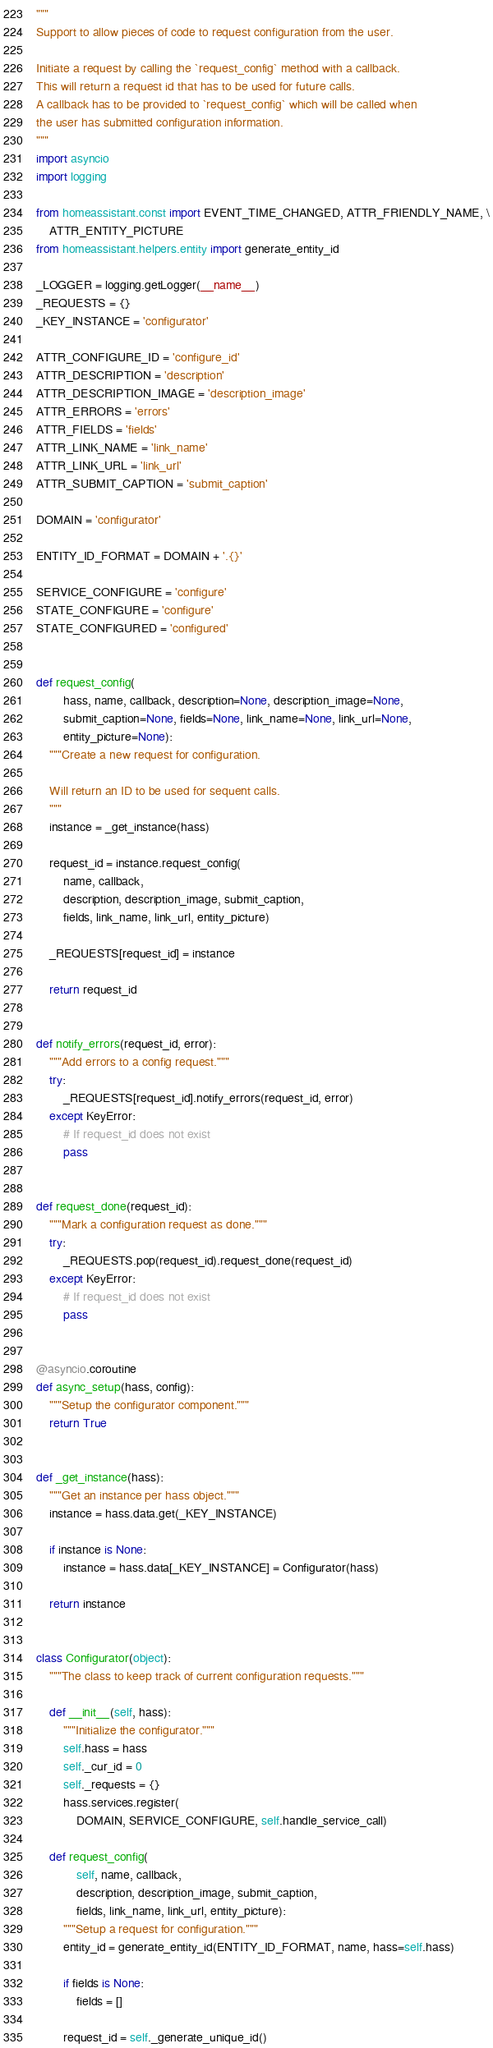Convert code to text. <code><loc_0><loc_0><loc_500><loc_500><_Python_>"""
Support to allow pieces of code to request configuration from the user.

Initiate a request by calling the `request_config` method with a callback.
This will return a request id that has to be used for future calls.
A callback has to be provided to `request_config` which will be called when
the user has submitted configuration information.
"""
import asyncio
import logging

from homeassistant.const import EVENT_TIME_CHANGED, ATTR_FRIENDLY_NAME, \
    ATTR_ENTITY_PICTURE
from homeassistant.helpers.entity import generate_entity_id

_LOGGER = logging.getLogger(__name__)
_REQUESTS = {}
_KEY_INSTANCE = 'configurator'

ATTR_CONFIGURE_ID = 'configure_id'
ATTR_DESCRIPTION = 'description'
ATTR_DESCRIPTION_IMAGE = 'description_image'
ATTR_ERRORS = 'errors'
ATTR_FIELDS = 'fields'
ATTR_LINK_NAME = 'link_name'
ATTR_LINK_URL = 'link_url'
ATTR_SUBMIT_CAPTION = 'submit_caption'

DOMAIN = 'configurator'

ENTITY_ID_FORMAT = DOMAIN + '.{}'

SERVICE_CONFIGURE = 'configure'
STATE_CONFIGURE = 'configure'
STATE_CONFIGURED = 'configured'


def request_config(
        hass, name, callback, description=None, description_image=None,
        submit_caption=None, fields=None, link_name=None, link_url=None,
        entity_picture=None):
    """Create a new request for configuration.

    Will return an ID to be used for sequent calls.
    """
    instance = _get_instance(hass)

    request_id = instance.request_config(
        name, callback,
        description, description_image, submit_caption,
        fields, link_name, link_url, entity_picture)

    _REQUESTS[request_id] = instance

    return request_id


def notify_errors(request_id, error):
    """Add errors to a config request."""
    try:
        _REQUESTS[request_id].notify_errors(request_id, error)
    except KeyError:
        # If request_id does not exist
        pass


def request_done(request_id):
    """Mark a configuration request as done."""
    try:
        _REQUESTS.pop(request_id).request_done(request_id)
    except KeyError:
        # If request_id does not exist
        pass


@asyncio.coroutine
def async_setup(hass, config):
    """Setup the configurator component."""
    return True


def _get_instance(hass):
    """Get an instance per hass object."""
    instance = hass.data.get(_KEY_INSTANCE)

    if instance is None:
        instance = hass.data[_KEY_INSTANCE] = Configurator(hass)

    return instance


class Configurator(object):
    """The class to keep track of current configuration requests."""

    def __init__(self, hass):
        """Initialize the configurator."""
        self.hass = hass
        self._cur_id = 0
        self._requests = {}
        hass.services.register(
            DOMAIN, SERVICE_CONFIGURE, self.handle_service_call)

    def request_config(
            self, name, callback,
            description, description_image, submit_caption,
            fields, link_name, link_url, entity_picture):
        """Setup a request for configuration."""
        entity_id = generate_entity_id(ENTITY_ID_FORMAT, name, hass=self.hass)

        if fields is None:
            fields = []

        request_id = self._generate_unique_id()
</code> 